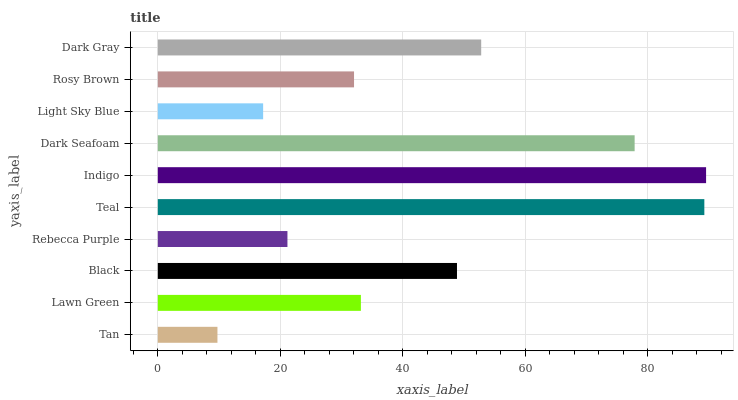Is Tan the minimum?
Answer yes or no. Yes. Is Indigo the maximum?
Answer yes or no. Yes. Is Lawn Green the minimum?
Answer yes or no. No. Is Lawn Green the maximum?
Answer yes or no. No. Is Lawn Green greater than Tan?
Answer yes or no. Yes. Is Tan less than Lawn Green?
Answer yes or no. Yes. Is Tan greater than Lawn Green?
Answer yes or no. No. Is Lawn Green less than Tan?
Answer yes or no. No. Is Black the high median?
Answer yes or no. Yes. Is Lawn Green the low median?
Answer yes or no. Yes. Is Tan the high median?
Answer yes or no. No. Is Teal the low median?
Answer yes or no. No. 